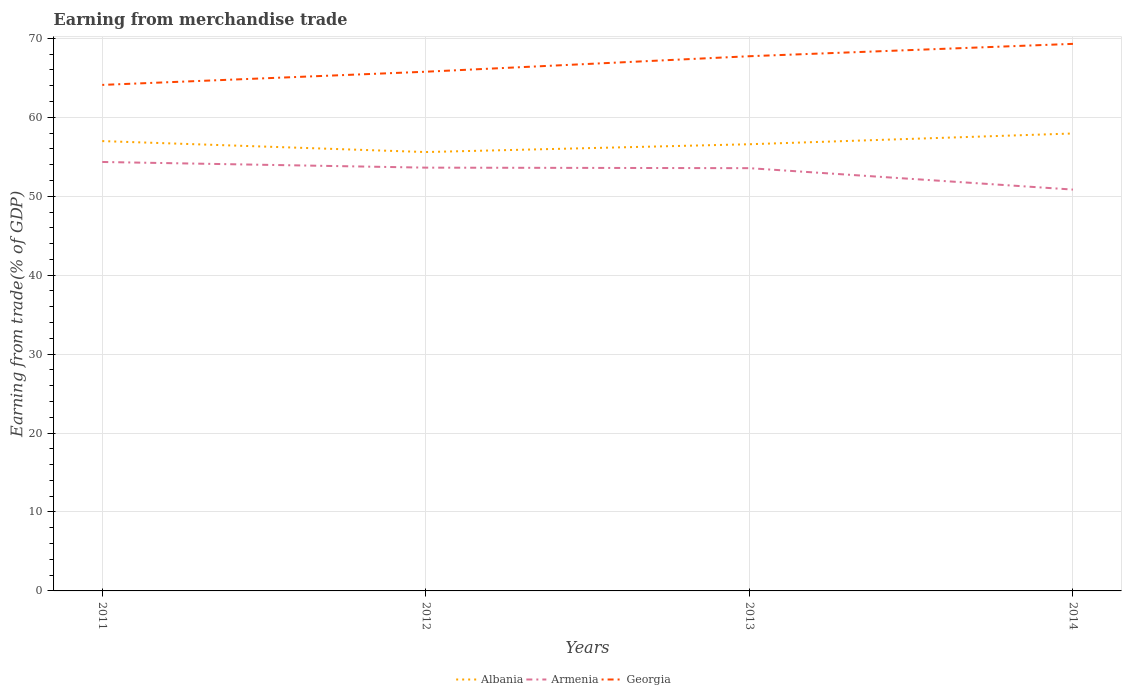How many different coloured lines are there?
Give a very brief answer. 3. Across all years, what is the maximum earnings from trade in Armenia?
Your response must be concise. 50.85. In which year was the earnings from trade in Armenia maximum?
Keep it short and to the point. 2014. What is the total earnings from trade in Georgia in the graph?
Give a very brief answer. -5.2. What is the difference between the highest and the second highest earnings from trade in Albania?
Your response must be concise. 2.35. What is the difference between the highest and the lowest earnings from trade in Albania?
Give a very brief answer. 2. What is the difference between two consecutive major ticks on the Y-axis?
Ensure brevity in your answer.  10. Are the values on the major ticks of Y-axis written in scientific E-notation?
Keep it short and to the point. No. How many legend labels are there?
Your response must be concise. 3. How are the legend labels stacked?
Your response must be concise. Horizontal. What is the title of the graph?
Make the answer very short. Earning from merchandise trade. What is the label or title of the X-axis?
Ensure brevity in your answer.  Years. What is the label or title of the Y-axis?
Make the answer very short. Earning from trade(% of GDP). What is the Earning from trade(% of GDP) in Albania in 2011?
Provide a succinct answer. 56.99. What is the Earning from trade(% of GDP) of Armenia in 2011?
Give a very brief answer. 54.35. What is the Earning from trade(% of GDP) of Georgia in 2011?
Offer a terse response. 64.11. What is the Earning from trade(% of GDP) in Albania in 2012?
Keep it short and to the point. 55.6. What is the Earning from trade(% of GDP) in Armenia in 2012?
Your answer should be compact. 53.63. What is the Earning from trade(% of GDP) in Georgia in 2012?
Offer a terse response. 65.78. What is the Earning from trade(% of GDP) in Albania in 2013?
Provide a succinct answer. 56.59. What is the Earning from trade(% of GDP) in Armenia in 2013?
Keep it short and to the point. 53.56. What is the Earning from trade(% of GDP) of Georgia in 2013?
Provide a short and direct response. 67.74. What is the Earning from trade(% of GDP) in Albania in 2014?
Your answer should be very brief. 57.96. What is the Earning from trade(% of GDP) of Armenia in 2014?
Provide a short and direct response. 50.85. What is the Earning from trade(% of GDP) of Georgia in 2014?
Your response must be concise. 69.31. Across all years, what is the maximum Earning from trade(% of GDP) in Albania?
Your response must be concise. 57.96. Across all years, what is the maximum Earning from trade(% of GDP) in Armenia?
Keep it short and to the point. 54.35. Across all years, what is the maximum Earning from trade(% of GDP) in Georgia?
Your answer should be very brief. 69.31. Across all years, what is the minimum Earning from trade(% of GDP) of Albania?
Your response must be concise. 55.6. Across all years, what is the minimum Earning from trade(% of GDP) in Armenia?
Your response must be concise. 50.85. Across all years, what is the minimum Earning from trade(% of GDP) of Georgia?
Make the answer very short. 64.11. What is the total Earning from trade(% of GDP) of Albania in the graph?
Keep it short and to the point. 227.14. What is the total Earning from trade(% of GDP) in Armenia in the graph?
Offer a very short reply. 212.38. What is the total Earning from trade(% of GDP) in Georgia in the graph?
Make the answer very short. 266.95. What is the difference between the Earning from trade(% of GDP) in Albania in 2011 and that in 2012?
Offer a terse response. 1.39. What is the difference between the Earning from trade(% of GDP) in Armenia in 2011 and that in 2012?
Your answer should be very brief. 0.72. What is the difference between the Earning from trade(% of GDP) of Georgia in 2011 and that in 2012?
Your answer should be compact. -1.67. What is the difference between the Earning from trade(% of GDP) of Albania in 2011 and that in 2013?
Your answer should be compact. 0.4. What is the difference between the Earning from trade(% of GDP) of Armenia in 2011 and that in 2013?
Provide a short and direct response. 0.78. What is the difference between the Earning from trade(% of GDP) in Georgia in 2011 and that in 2013?
Your response must be concise. -3.63. What is the difference between the Earning from trade(% of GDP) of Albania in 2011 and that in 2014?
Make the answer very short. -0.96. What is the difference between the Earning from trade(% of GDP) in Armenia in 2011 and that in 2014?
Offer a terse response. 3.5. What is the difference between the Earning from trade(% of GDP) in Georgia in 2011 and that in 2014?
Offer a terse response. -5.2. What is the difference between the Earning from trade(% of GDP) in Albania in 2012 and that in 2013?
Provide a succinct answer. -0.99. What is the difference between the Earning from trade(% of GDP) in Armenia in 2012 and that in 2013?
Give a very brief answer. 0.07. What is the difference between the Earning from trade(% of GDP) in Georgia in 2012 and that in 2013?
Your answer should be very brief. -1.96. What is the difference between the Earning from trade(% of GDP) of Albania in 2012 and that in 2014?
Give a very brief answer. -2.35. What is the difference between the Earning from trade(% of GDP) in Armenia in 2012 and that in 2014?
Offer a terse response. 2.78. What is the difference between the Earning from trade(% of GDP) of Georgia in 2012 and that in 2014?
Your answer should be very brief. -3.53. What is the difference between the Earning from trade(% of GDP) in Albania in 2013 and that in 2014?
Offer a terse response. -1.36. What is the difference between the Earning from trade(% of GDP) in Armenia in 2013 and that in 2014?
Give a very brief answer. 2.71. What is the difference between the Earning from trade(% of GDP) of Georgia in 2013 and that in 2014?
Keep it short and to the point. -1.57. What is the difference between the Earning from trade(% of GDP) in Albania in 2011 and the Earning from trade(% of GDP) in Armenia in 2012?
Provide a short and direct response. 3.36. What is the difference between the Earning from trade(% of GDP) in Albania in 2011 and the Earning from trade(% of GDP) in Georgia in 2012?
Give a very brief answer. -8.79. What is the difference between the Earning from trade(% of GDP) in Armenia in 2011 and the Earning from trade(% of GDP) in Georgia in 2012?
Offer a very short reply. -11.43. What is the difference between the Earning from trade(% of GDP) in Albania in 2011 and the Earning from trade(% of GDP) in Armenia in 2013?
Your response must be concise. 3.43. What is the difference between the Earning from trade(% of GDP) in Albania in 2011 and the Earning from trade(% of GDP) in Georgia in 2013?
Offer a terse response. -10.75. What is the difference between the Earning from trade(% of GDP) of Armenia in 2011 and the Earning from trade(% of GDP) of Georgia in 2013?
Offer a terse response. -13.4. What is the difference between the Earning from trade(% of GDP) of Albania in 2011 and the Earning from trade(% of GDP) of Armenia in 2014?
Provide a short and direct response. 6.14. What is the difference between the Earning from trade(% of GDP) in Albania in 2011 and the Earning from trade(% of GDP) in Georgia in 2014?
Your answer should be very brief. -12.32. What is the difference between the Earning from trade(% of GDP) of Armenia in 2011 and the Earning from trade(% of GDP) of Georgia in 2014?
Your response must be concise. -14.96. What is the difference between the Earning from trade(% of GDP) in Albania in 2012 and the Earning from trade(% of GDP) in Armenia in 2013?
Your answer should be compact. 2.04. What is the difference between the Earning from trade(% of GDP) in Albania in 2012 and the Earning from trade(% of GDP) in Georgia in 2013?
Keep it short and to the point. -12.14. What is the difference between the Earning from trade(% of GDP) of Armenia in 2012 and the Earning from trade(% of GDP) of Georgia in 2013?
Offer a very short reply. -14.12. What is the difference between the Earning from trade(% of GDP) of Albania in 2012 and the Earning from trade(% of GDP) of Armenia in 2014?
Your answer should be compact. 4.76. What is the difference between the Earning from trade(% of GDP) of Albania in 2012 and the Earning from trade(% of GDP) of Georgia in 2014?
Your answer should be very brief. -13.71. What is the difference between the Earning from trade(% of GDP) of Armenia in 2012 and the Earning from trade(% of GDP) of Georgia in 2014?
Make the answer very short. -15.68. What is the difference between the Earning from trade(% of GDP) in Albania in 2013 and the Earning from trade(% of GDP) in Armenia in 2014?
Give a very brief answer. 5.75. What is the difference between the Earning from trade(% of GDP) in Albania in 2013 and the Earning from trade(% of GDP) in Georgia in 2014?
Your answer should be compact. -12.72. What is the difference between the Earning from trade(% of GDP) in Armenia in 2013 and the Earning from trade(% of GDP) in Georgia in 2014?
Offer a very short reply. -15.75. What is the average Earning from trade(% of GDP) of Albania per year?
Offer a terse response. 56.79. What is the average Earning from trade(% of GDP) of Armenia per year?
Offer a terse response. 53.1. What is the average Earning from trade(% of GDP) in Georgia per year?
Your response must be concise. 66.74. In the year 2011, what is the difference between the Earning from trade(% of GDP) in Albania and Earning from trade(% of GDP) in Armenia?
Make the answer very short. 2.65. In the year 2011, what is the difference between the Earning from trade(% of GDP) in Albania and Earning from trade(% of GDP) in Georgia?
Provide a short and direct response. -7.12. In the year 2011, what is the difference between the Earning from trade(% of GDP) in Armenia and Earning from trade(% of GDP) in Georgia?
Ensure brevity in your answer.  -9.76. In the year 2012, what is the difference between the Earning from trade(% of GDP) in Albania and Earning from trade(% of GDP) in Armenia?
Provide a succinct answer. 1.98. In the year 2012, what is the difference between the Earning from trade(% of GDP) in Albania and Earning from trade(% of GDP) in Georgia?
Provide a short and direct response. -10.18. In the year 2012, what is the difference between the Earning from trade(% of GDP) in Armenia and Earning from trade(% of GDP) in Georgia?
Provide a short and direct response. -12.15. In the year 2013, what is the difference between the Earning from trade(% of GDP) in Albania and Earning from trade(% of GDP) in Armenia?
Your answer should be compact. 3.03. In the year 2013, what is the difference between the Earning from trade(% of GDP) in Albania and Earning from trade(% of GDP) in Georgia?
Provide a succinct answer. -11.15. In the year 2013, what is the difference between the Earning from trade(% of GDP) in Armenia and Earning from trade(% of GDP) in Georgia?
Offer a terse response. -14.18. In the year 2014, what is the difference between the Earning from trade(% of GDP) in Albania and Earning from trade(% of GDP) in Armenia?
Ensure brevity in your answer.  7.11. In the year 2014, what is the difference between the Earning from trade(% of GDP) of Albania and Earning from trade(% of GDP) of Georgia?
Offer a very short reply. -11.35. In the year 2014, what is the difference between the Earning from trade(% of GDP) in Armenia and Earning from trade(% of GDP) in Georgia?
Ensure brevity in your answer.  -18.46. What is the ratio of the Earning from trade(% of GDP) of Armenia in 2011 to that in 2012?
Provide a succinct answer. 1.01. What is the ratio of the Earning from trade(% of GDP) of Georgia in 2011 to that in 2012?
Provide a succinct answer. 0.97. What is the ratio of the Earning from trade(% of GDP) of Albania in 2011 to that in 2013?
Offer a terse response. 1.01. What is the ratio of the Earning from trade(% of GDP) of Armenia in 2011 to that in 2013?
Provide a short and direct response. 1.01. What is the ratio of the Earning from trade(% of GDP) of Georgia in 2011 to that in 2013?
Provide a short and direct response. 0.95. What is the ratio of the Earning from trade(% of GDP) of Albania in 2011 to that in 2014?
Your answer should be compact. 0.98. What is the ratio of the Earning from trade(% of GDP) of Armenia in 2011 to that in 2014?
Ensure brevity in your answer.  1.07. What is the ratio of the Earning from trade(% of GDP) in Georgia in 2011 to that in 2014?
Ensure brevity in your answer.  0.93. What is the ratio of the Earning from trade(% of GDP) of Albania in 2012 to that in 2013?
Provide a succinct answer. 0.98. What is the ratio of the Earning from trade(% of GDP) of Georgia in 2012 to that in 2013?
Your response must be concise. 0.97. What is the ratio of the Earning from trade(% of GDP) in Albania in 2012 to that in 2014?
Offer a terse response. 0.96. What is the ratio of the Earning from trade(% of GDP) of Armenia in 2012 to that in 2014?
Provide a short and direct response. 1.05. What is the ratio of the Earning from trade(% of GDP) in Georgia in 2012 to that in 2014?
Your answer should be compact. 0.95. What is the ratio of the Earning from trade(% of GDP) in Albania in 2013 to that in 2014?
Your answer should be very brief. 0.98. What is the ratio of the Earning from trade(% of GDP) in Armenia in 2013 to that in 2014?
Ensure brevity in your answer.  1.05. What is the ratio of the Earning from trade(% of GDP) of Georgia in 2013 to that in 2014?
Your answer should be compact. 0.98. What is the difference between the highest and the second highest Earning from trade(% of GDP) in Albania?
Offer a terse response. 0.96. What is the difference between the highest and the second highest Earning from trade(% of GDP) in Armenia?
Provide a short and direct response. 0.72. What is the difference between the highest and the second highest Earning from trade(% of GDP) in Georgia?
Offer a terse response. 1.57. What is the difference between the highest and the lowest Earning from trade(% of GDP) in Albania?
Your answer should be very brief. 2.35. What is the difference between the highest and the lowest Earning from trade(% of GDP) of Armenia?
Ensure brevity in your answer.  3.5. What is the difference between the highest and the lowest Earning from trade(% of GDP) in Georgia?
Make the answer very short. 5.2. 